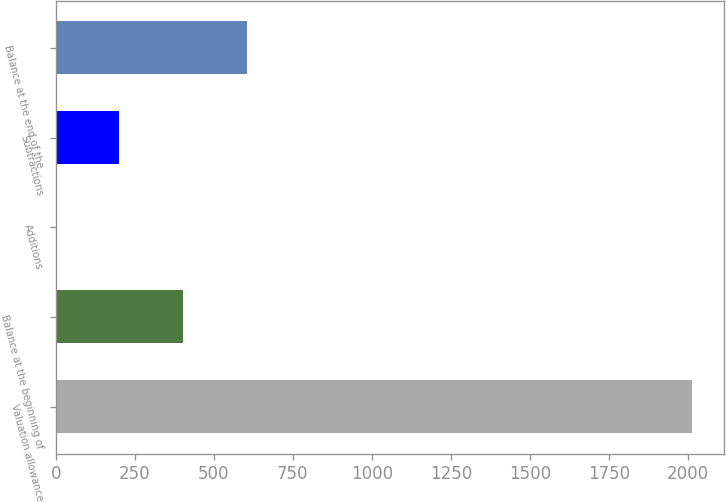Convert chart. <chart><loc_0><loc_0><loc_500><loc_500><bar_chart><fcel>Valuation allowance<fcel>Balance at the beginning of<fcel>Additions<fcel>Subtractions<fcel>Balance at the end of the<nl><fcel>2012<fcel>402.7<fcel>0.38<fcel>201.54<fcel>603.86<nl></chart> 